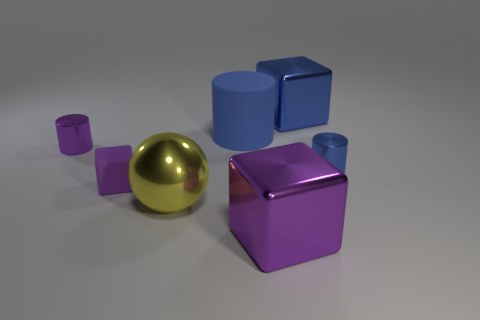Is there any other thing of the same color as the large sphere?
Your answer should be compact. No. There is a blue cylinder on the right side of the big purple shiny object; is its size the same as the blue cylinder to the left of the blue metal cylinder?
Ensure brevity in your answer.  No. What color is the small object behind the cylinder to the right of the purple thing that is to the right of the large rubber cylinder?
Your answer should be compact. Purple. Are there any other purple rubber things of the same shape as the tiny purple matte thing?
Your response must be concise. No. Is the number of big rubber cylinders on the left side of the tiny matte thing greater than the number of large yellow metallic cylinders?
Provide a succinct answer. No. What number of matte things are small purple blocks or small purple cylinders?
Ensure brevity in your answer.  1. There is a metal thing that is both on the left side of the big purple cube and in front of the tiny rubber cube; how big is it?
Ensure brevity in your answer.  Large. Are there any large purple blocks in front of the big metallic cube in front of the yellow sphere?
Make the answer very short. No. What number of tiny metallic cylinders are left of the blue matte object?
Offer a very short reply. 1. What color is the small rubber thing that is the same shape as the large purple thing?
Make the answer very short. Purple. 